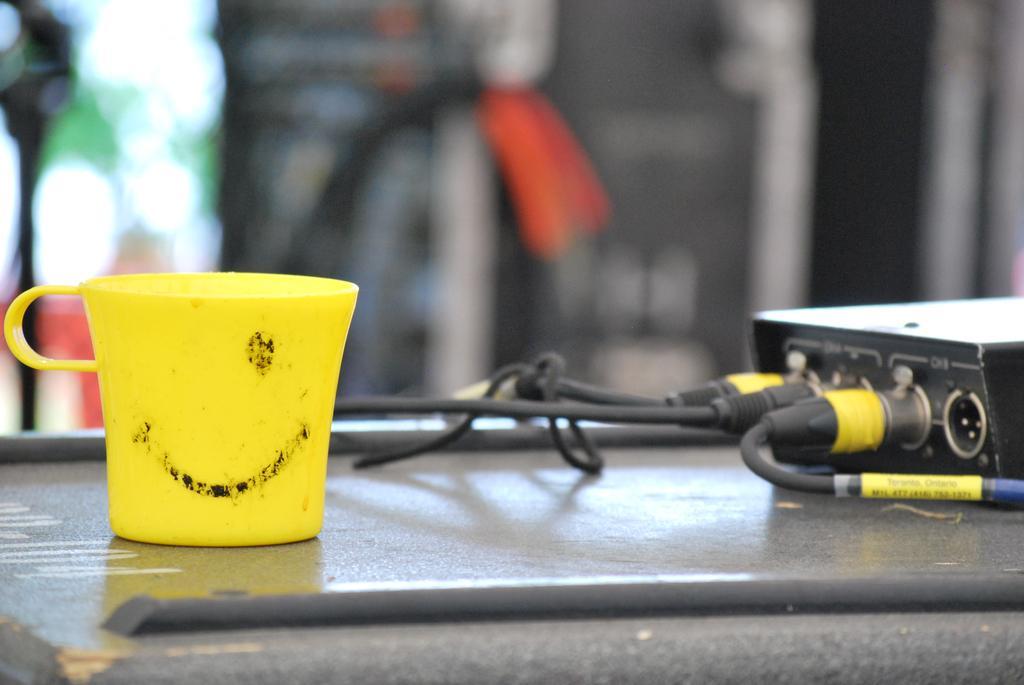How would you summarize this image in a sentence or two? In this image I can see a cup which is in yellow color on some surface. In front I can see few wires in black color and I can see blurred background. 